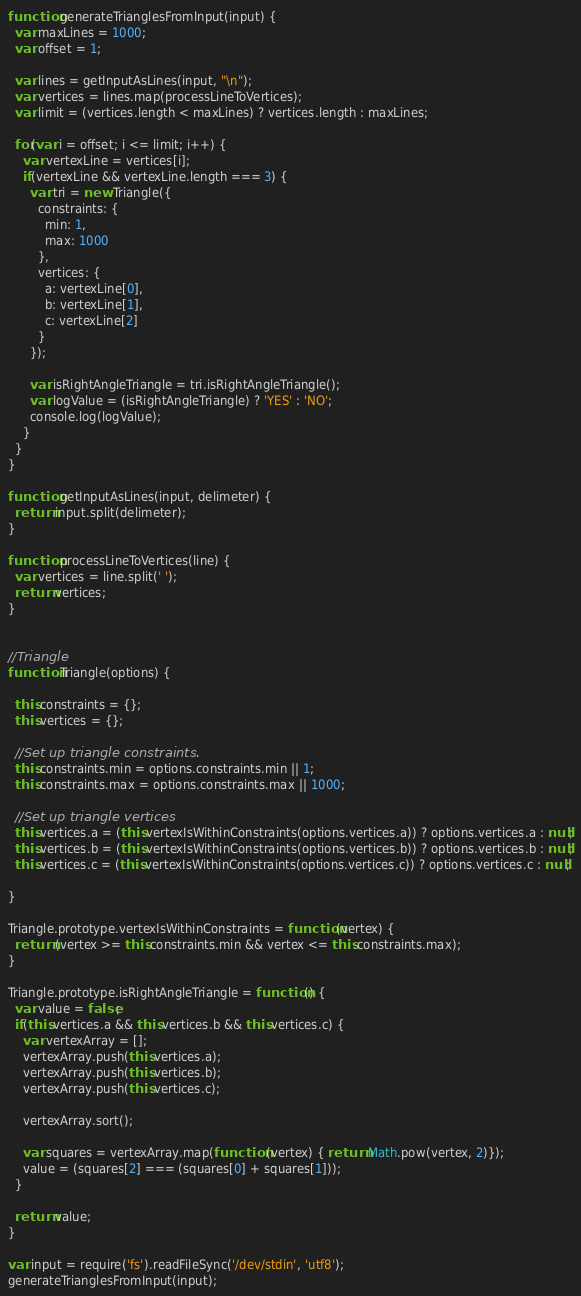Convert code to text. <code><loc_0><loc_0><loc_500><loc_500><_JavaScript_>function generateTrianglesFromInput(input) {
  var maxLines = 1000;
  var offset = 1;

  var lines = getInputAsLines(input, "\n");
  var vertices = lines.map(processLineToVertices);
  var limit = (vertices.length < maxLines) ? vertices.length : maxLines;

  for(var i = offset; i <= limit; i++) {
    var vertexLine = vertices[i];
    if(vertexLine && vertexLine.length === 3) {
      var tri = new Triangle({
        constraints: {
          min: 1,
          max: 1000
        },
        vertices: {
          a: vertexLine[0],
          b: vertexLine[1],
          c: vertexLine[2]
        }
      });

      var isRightAngleTriangle = tri.isRightAngleTriangle();
      var logValue = (isRightAngleTriangle) ? 'YES' : 'NO';
      console.log(logValue);
    }
  }
}

function getInputAsLines(input, delimeter) {
  return input.split(delimeter);
}

function processLineToVertices(line) {
  var vertices = line.split(' ');
  return vertices;
}


//Triangle
function Triangle(options) {

  this.constraints = {};
  this.vertices = {};

  //Set up triangle constraints.
  this.constraints.min = options.constraints.min || 1;
  this.constraints.max = options.constraints.max || 1000;

  //Set up triangle vertices
  this.vertices.a = (this.vertexIsWithinConstraints(options.vertices.a)) ? options.vertices.a : null;
  this.vertices.b = (this.vertexIsWithinConstraints(options.vertices.b)) ? options.vertices.b : null;
  this.vertices.c = (this.vertexIsWithinConstraints(options.vertices.c)) ? options.vertices.c : null;

}

Triangle.prototype.vertexIsWithinConstraints = function(vertex) {
  return (vertex >= this.constraints.min && vertex <= this.constraints.max);
}

Triangle.prototype.isRightAngleTriangle = function() {
  var value = false;
  if(this.vertices.a && this.vertices.b && this.vertices.c) {
    var vertexArray = [];
    vertexArray.push(this.vertices.a);
    vertexArray.push(this.vertices.b);
    vertexArray.push(this.vertices.c);

    vertexArray.sort();

    var squares = vertexArray.map(function (vertex) { return Math.pow(vertex, 2)});
    value = (squares[2] === (squares[0] + squares[1]));
  }

  return value;
}

var input = require('fs').readFileSync('/dev/stdin', 'utf8');
generateTrianglesFromInput(input);</code> 